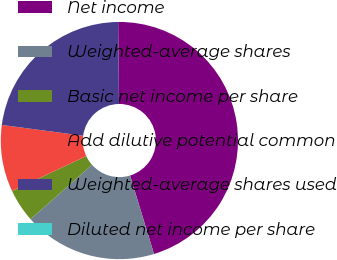Convert chart. <chart><loc_0><loc_0><loc_500><loc_500><pie_chart><fcel>Net income<fcel>Weighted-average shares<fcel>Basic net income per share<fcel>Add dilutive potential common<fcel>Weighted-average shares used<fcel>Diluted net income per share<nl><fcel>45.45%<fcel>18.18%<fcel>4.55%<fcel>9.09%<fcel>22.73%<fcel>0.0%<nl></chart> 